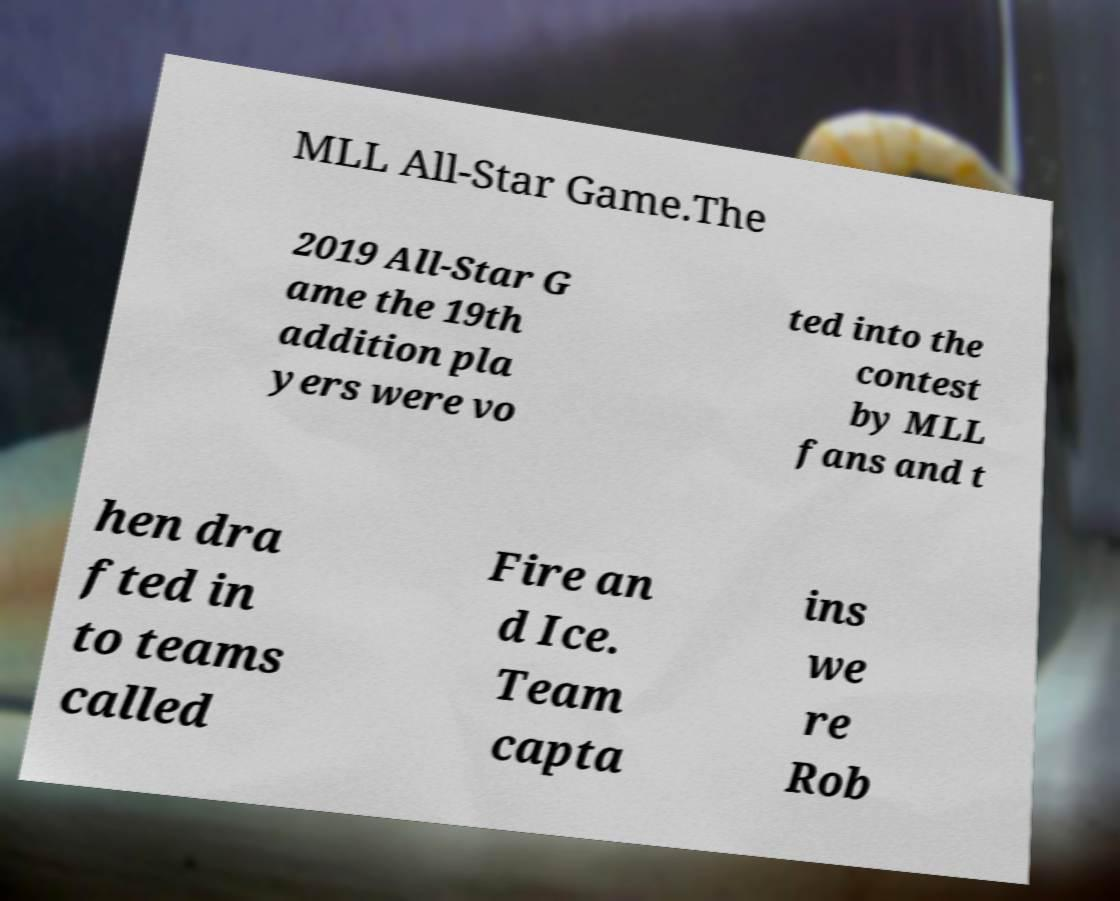There's text embedded in this image that I need extracted. Can you transcribe it verbatim? MLL All-Star Game.The 2019 All-Star G ame the 19th addition pla yers were vo ted into the contest by MLL fans and t hen dra fted in to teams called Fire an d Ice. Team capta ins we re Rob 